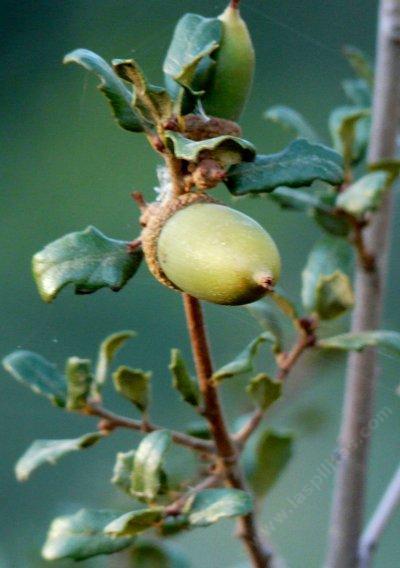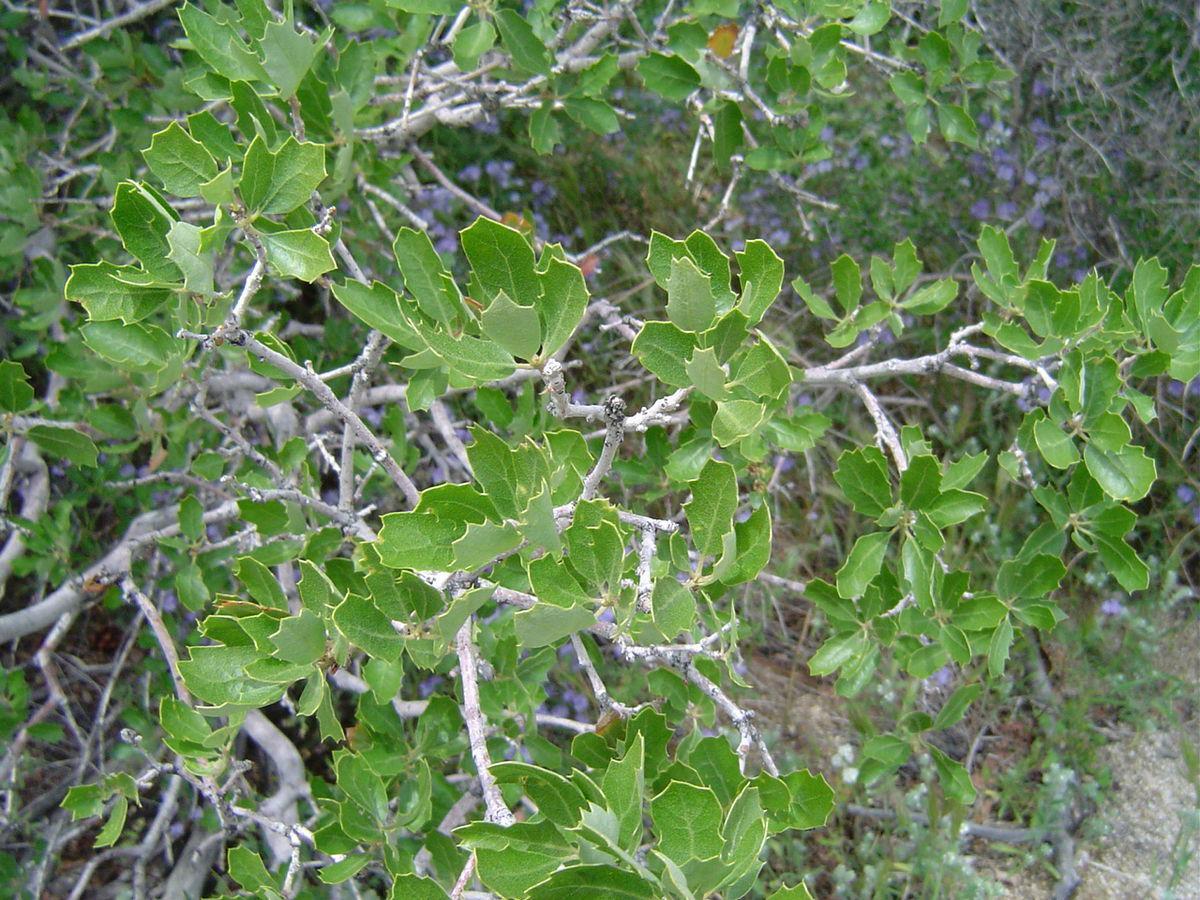The first image is the image on the left, the second image is the image on the right. Evaluate the accuracy of this statement regarding the images: "The left image shows two green acorns in the foreground which lack any brown patches on their skins, and the right image shows foliage without individually distinguishable acorns.". Is it true? Answer yes or no. Yes. The first image is the image on the left, the second image is the image on the right. Given the left and right images, does the statement "One of the images is an acorn close up and the other only shows branches and leaves." hold true? Answer yes or no. Yes. 